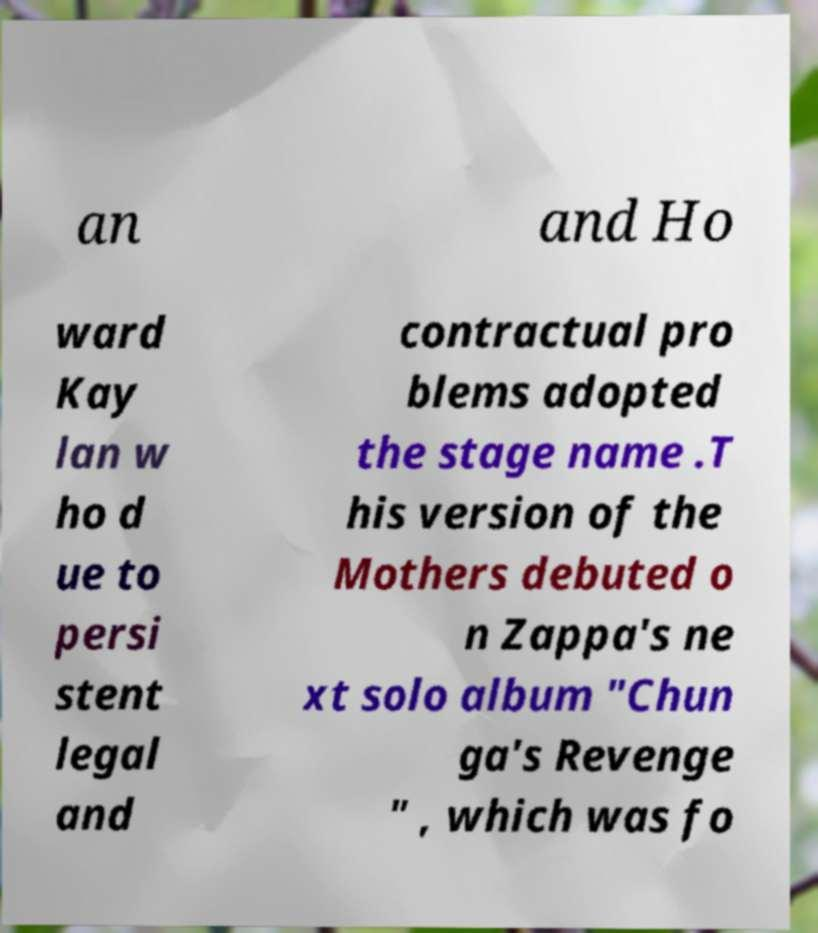Could you assist in decoding the text presented in this image and type it out clearly? an and Ho ward Kay lan w ho d ue to persi stent legal and contractual pro blems adopted the stage name .T his version of the Mothers debuted o n Zappa's ne xt solo album "Chun ga's Revenge " , which was fo 